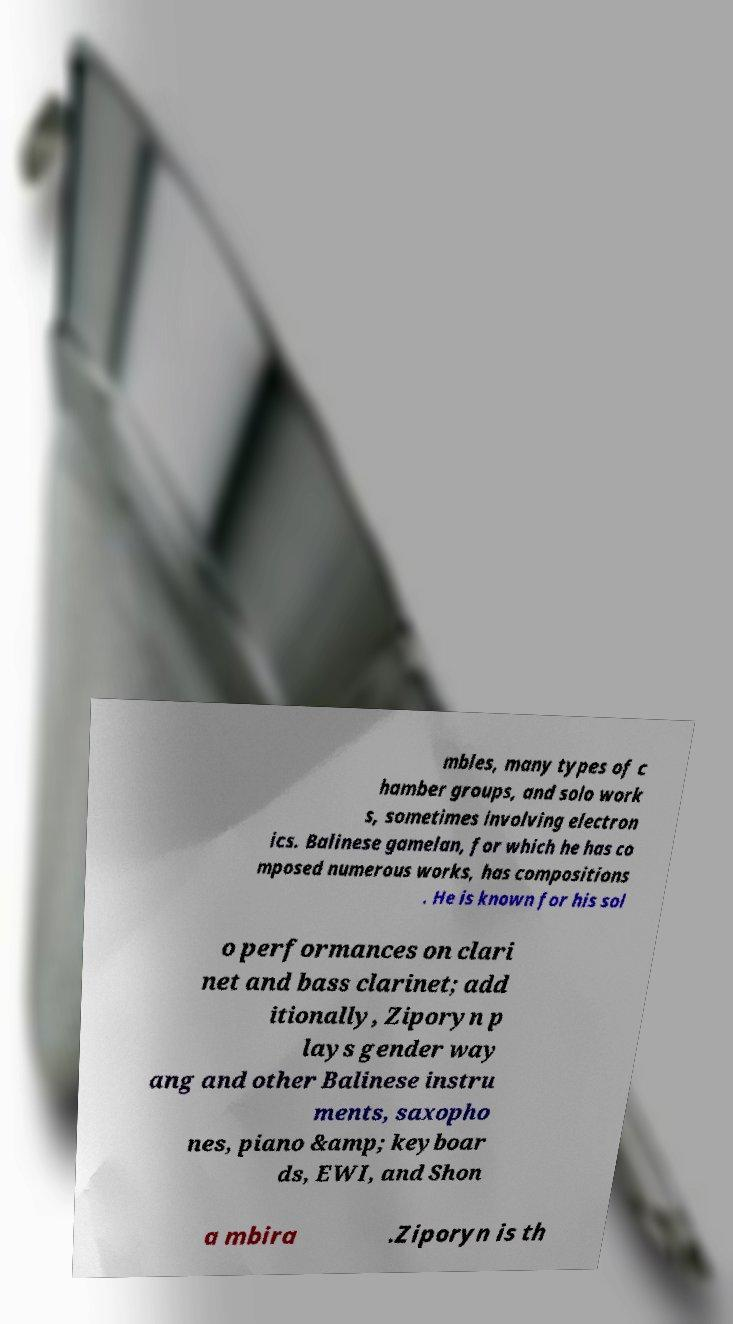Could you assist in decoding the text presented in this image and type it out clearly? mbles, many types of c hamber groups, and solo work s, sometimes involving electron ics. Balinese gamelan, for which he has co mposed numerous works, has compositions . He is known for his sol o performances on clari net and bass clarinet; add itionally, Ziporyn p lays gender way ang and other Balinese instru ments, saxopho nes, piano &amp; keyboar ds, EWI, and Shon a mbira .Ziporyn is th 